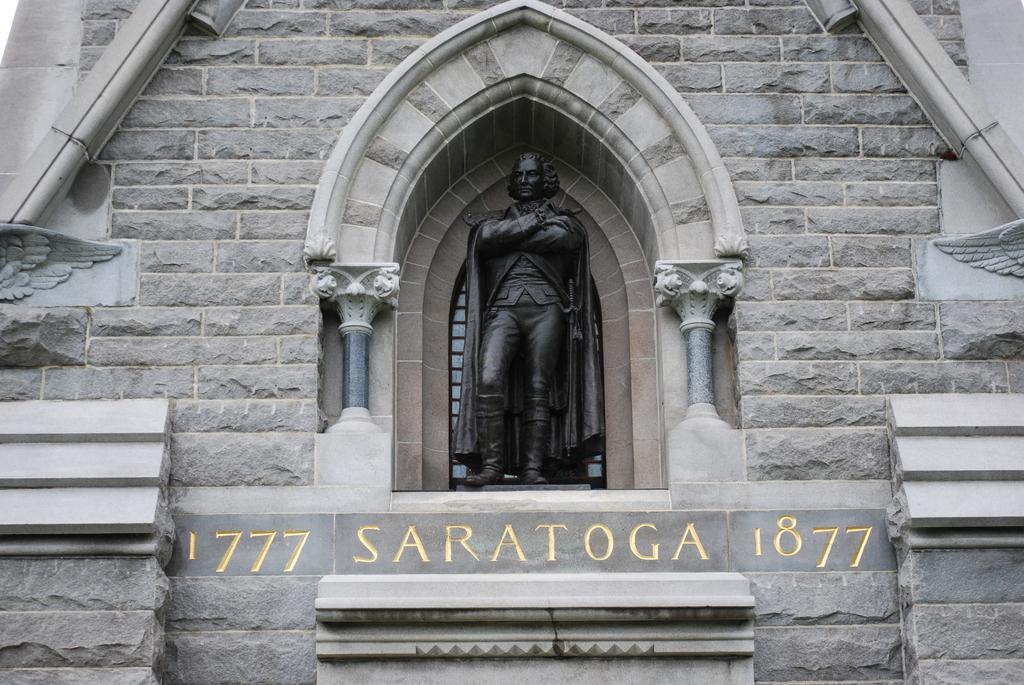How would you summarize this image in a sentence or two? In this image there is a wall of a building. There is text on the building. In the center there is a sculpture of a man on the wall. 